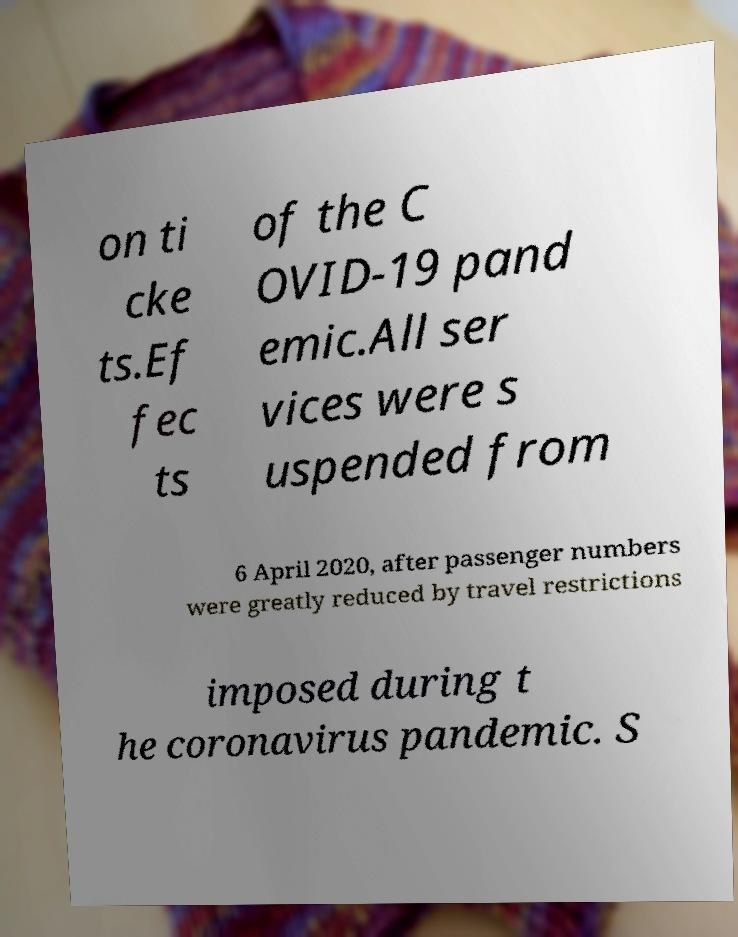Could you extract and type out the text from this image? on ti cke ts.Ef fec ts of the C OVID-19 pand emic.All ser vices were s uspended from 6 April 2020, after passenger numbers were greatly reduced by travel restrictions imposed during t he coronavirus pandemic. S 